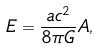Convert formula to latex. <formula><loc_0><loc_0><loc_500><loc_500>E = \frac { a c ^ { 2 } } { 8 \pi G } A ,</formula> 